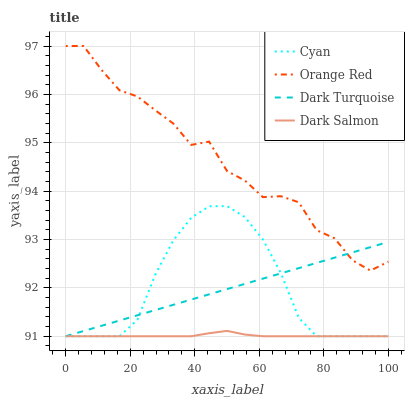Does Dark Salmon have the minimum area under the curve?
Answer yes or no. Yes. Does Orange Red have the maximum area under the curve?
Answer yes or no. Yes. Does Orange Red have the minimum area under the curve?
Answer yes or no. No. Does Dark Salmon have the maximum area under the curve?
Answer yes or no. No. Is Dark Turquoise the smoothest?
Answer yes or no. Yes. Is Orange Red the roughest?
Answer yes or no. Yes. Is Dark Salmon the smoothest?
Answer yes or no. No. Is Dark Salmon the roughest?
Answer yes or no. No. Does Cyan have the lowest value?
Answer yes or no. Yes. Does Orange Red have the lowest value?
Answer yes or no. No. Does Orange Red have the highest value?
Answer yes or no. Yes. Does Dark Salmon have the highest value?
Answer yes or no. No. Is Cyan less than Orange Red?
Answer yes or no. Yes. Is Orange Red greater than Dark Salmon?
Answer yes or no. Yes. Does Dark Turquoise intersect Dark Salmon?
Answer yes or no. Yes. Is Dark Turquoise less than Dark Salmon?
Answer yes or no. No. Is Dark Turquoise greater than Dark Salmon?
Answer yes or no. No. Does Cyan intersect Orange Red?
Answer yes or no. No. 